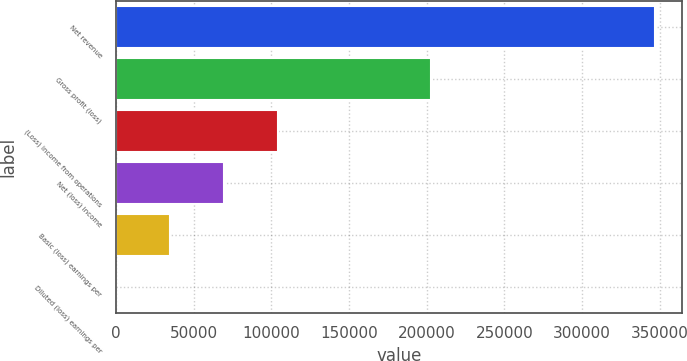<chart> <loc_0><loc_0><loc_500><loc_500><bar_chart><fcel>Net revenue<fcel>Gross profit (loss)<fcel>(Loss) income from operations<fcel>Net (loss) income<fcel>Basic (loss) earnings per<fcel>Diluted (loss) earnings per<nl><fcel>346974<fcel>203034<fcel>104093<fcel>69395.2<fcel>34697.9<fcel>0.55<nl></chart> 